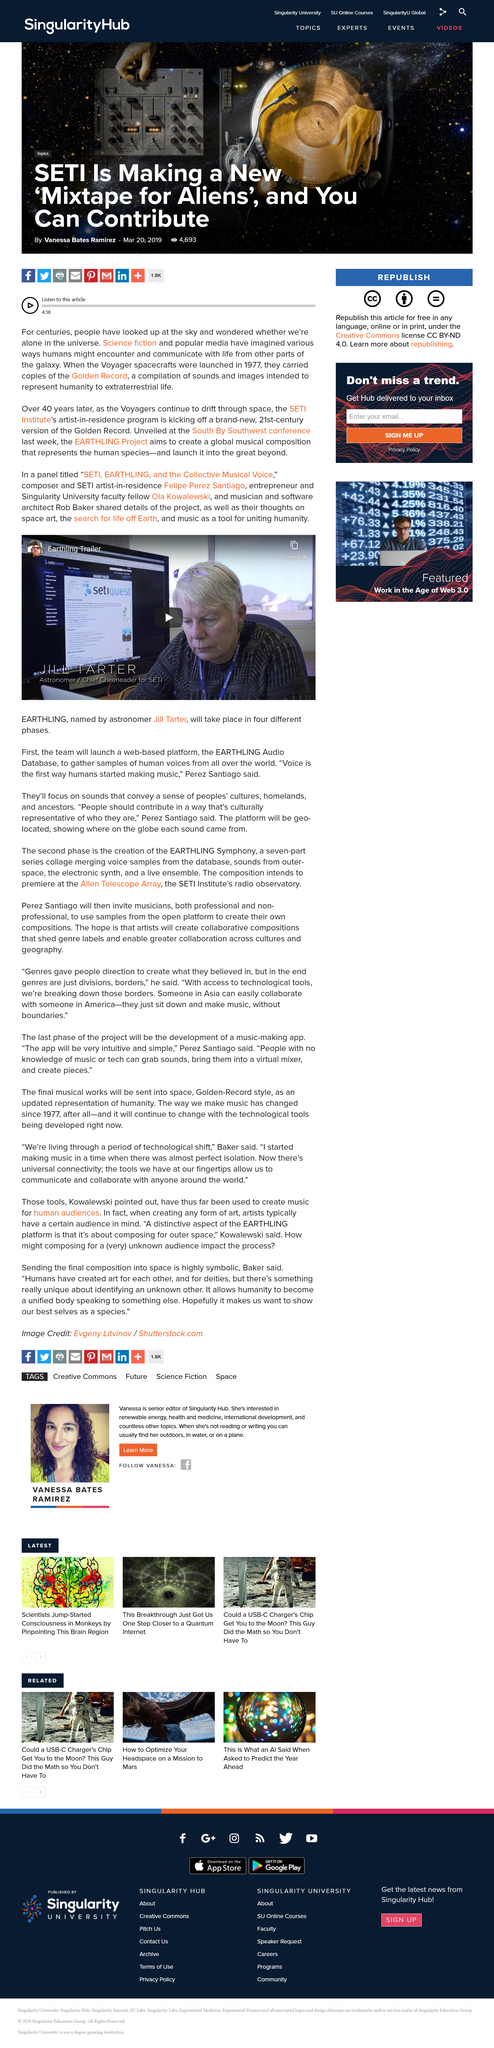List a handful of essential elements in this visual. Who said, 'Voice is the first way humans started making music'? Perez Santiago, himself. The video features Jill Tarter, an astronomer. The EARTHLING Audio Database will be a web-based platform, as declared. 